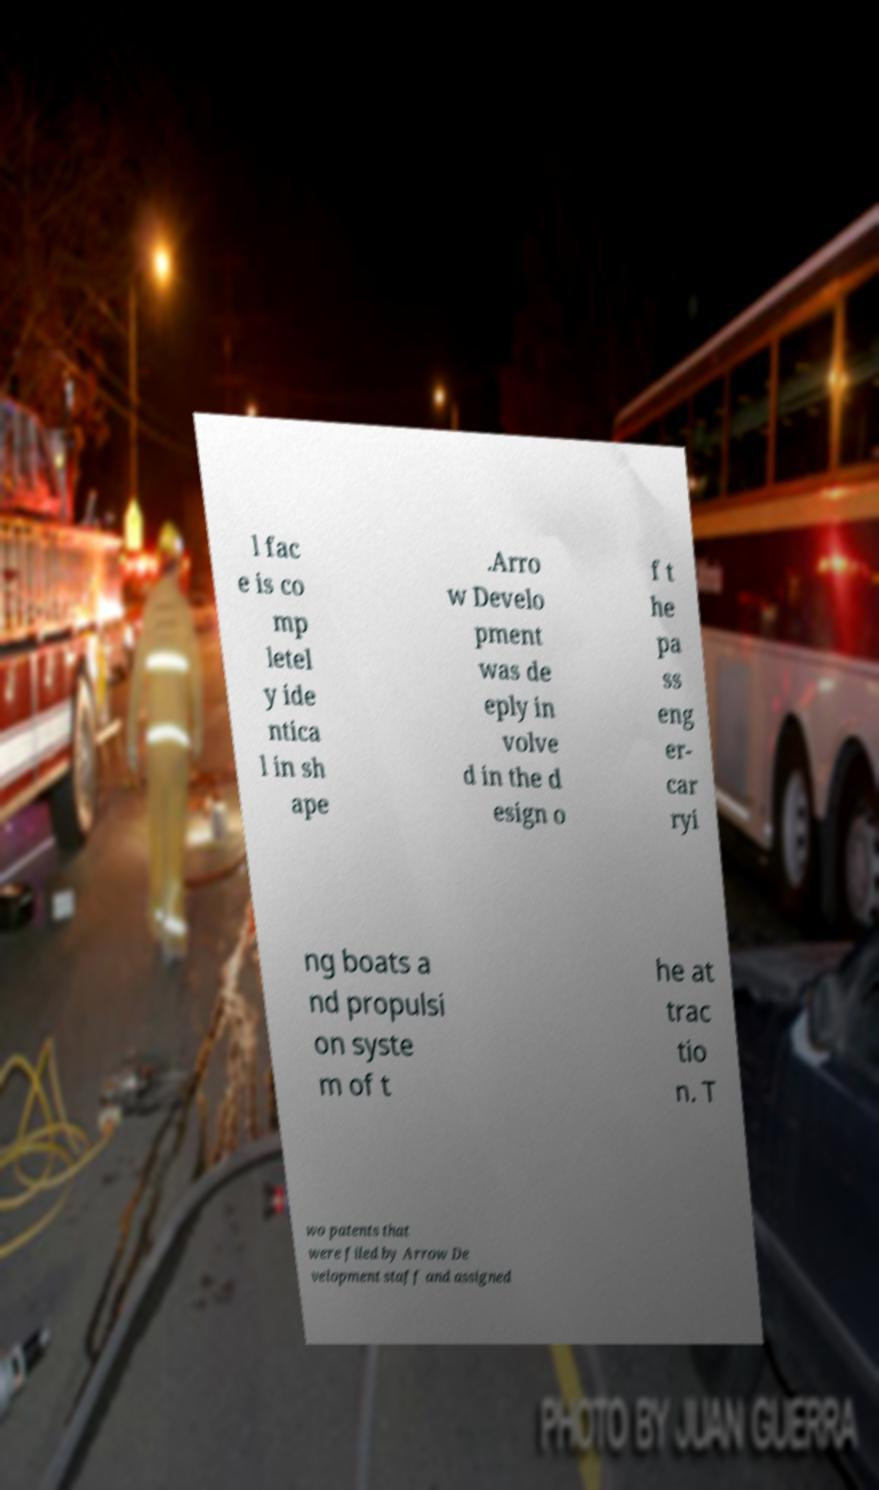I need the written content from this picture converted into text. Can you do that? l fac e is co mp letel y ide ntica l in sh ape .Arro w Develo pment was de eply in volve d in the d esign o f t he pa ss eng er- car ryi ng boats a nd propulsi on syste m of t he at trac tio n. T wo patents that were filed by Arrow De velopment staff and assigned 